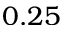<formula> <loc_0><loc_0><loc_500><loc_500>0 . 2 5</formula> 